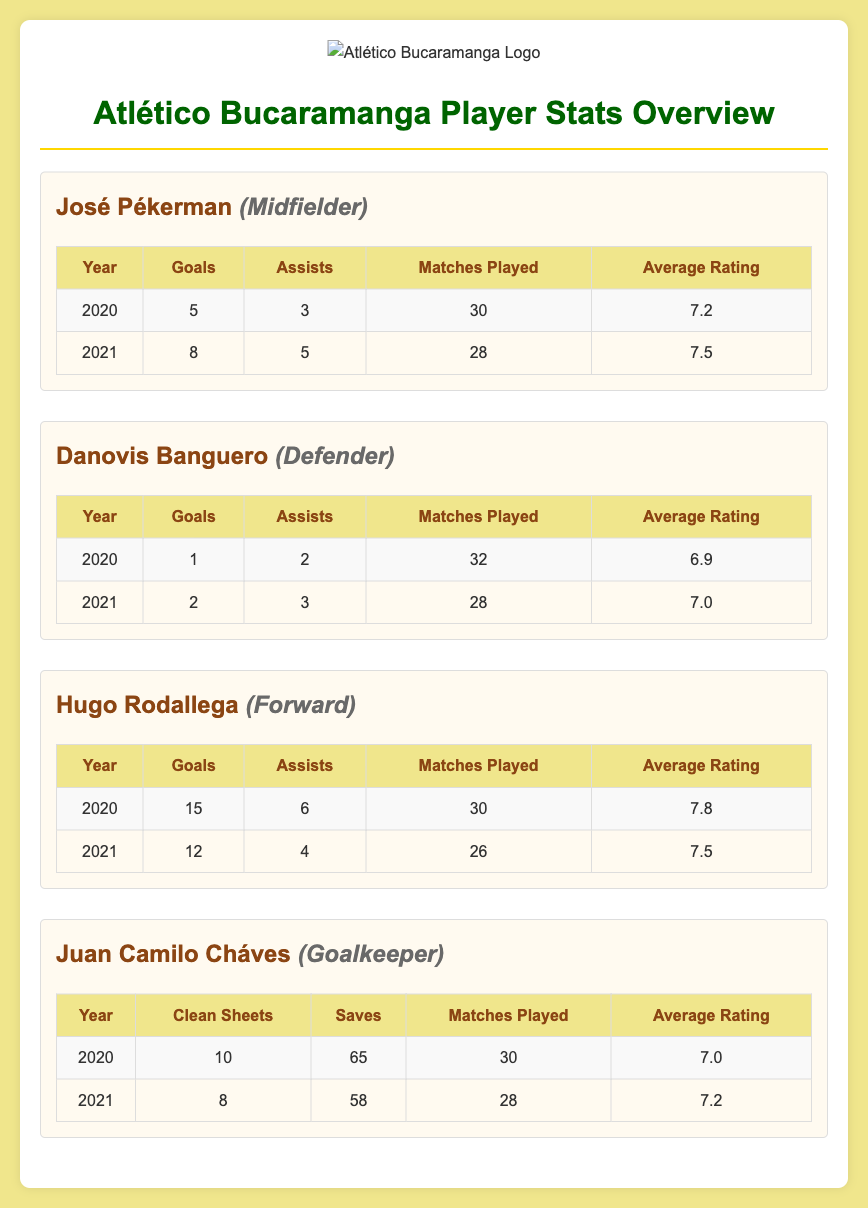What is José Pékerman's highest number of goals? The highest number of goals José Pékerman scored is listed in 2021 with 8 goals.
Answer: 8 How many assists did Danovis Banguero make in 2020? The number of assists Danovis Banguero made in 2020 is indicated as 2 assists.
Answer: 2 What is the average rating of Hugo Rodallega in 2020? The average rating for Hugo Rodallega in 2020 is stated as 7.8.
Answer: 7.8 What position does Juan Camilo Cháves play? The position of Juan Camilo Cháves is designated as Goalkeeper in the document.
Answer: Goalkeeper Which player had the most matches played in 2021? The player with the most matches played in 2021 is José Pékerman with 28 matches.
Answer: José Pékerman What was Danovis Banguero's goal count in 2021? Danovis Banguero's goal count for the year 2021 is presented as 2 goals.
Answer: 2 How many clean sheets did Juan Camilo Cháves achieve in 2020? The clean sheets for Juan Camilo Cháves in 2020 are disclosed as 10.
Answer: 10 What is Hugo Rodallega’s total number of assists in 2020 and 2021? The total number of assists for Hugo Rodallega is 6 in 2020 plus 4 in 2021, which sums to 10.
Answer: 10 Which player had the lowest average rating in 2020? The player with the lowest average rating in 2020 is Danovis Banguero with a rating of 6.9.
Answer: Danovis Banguero 